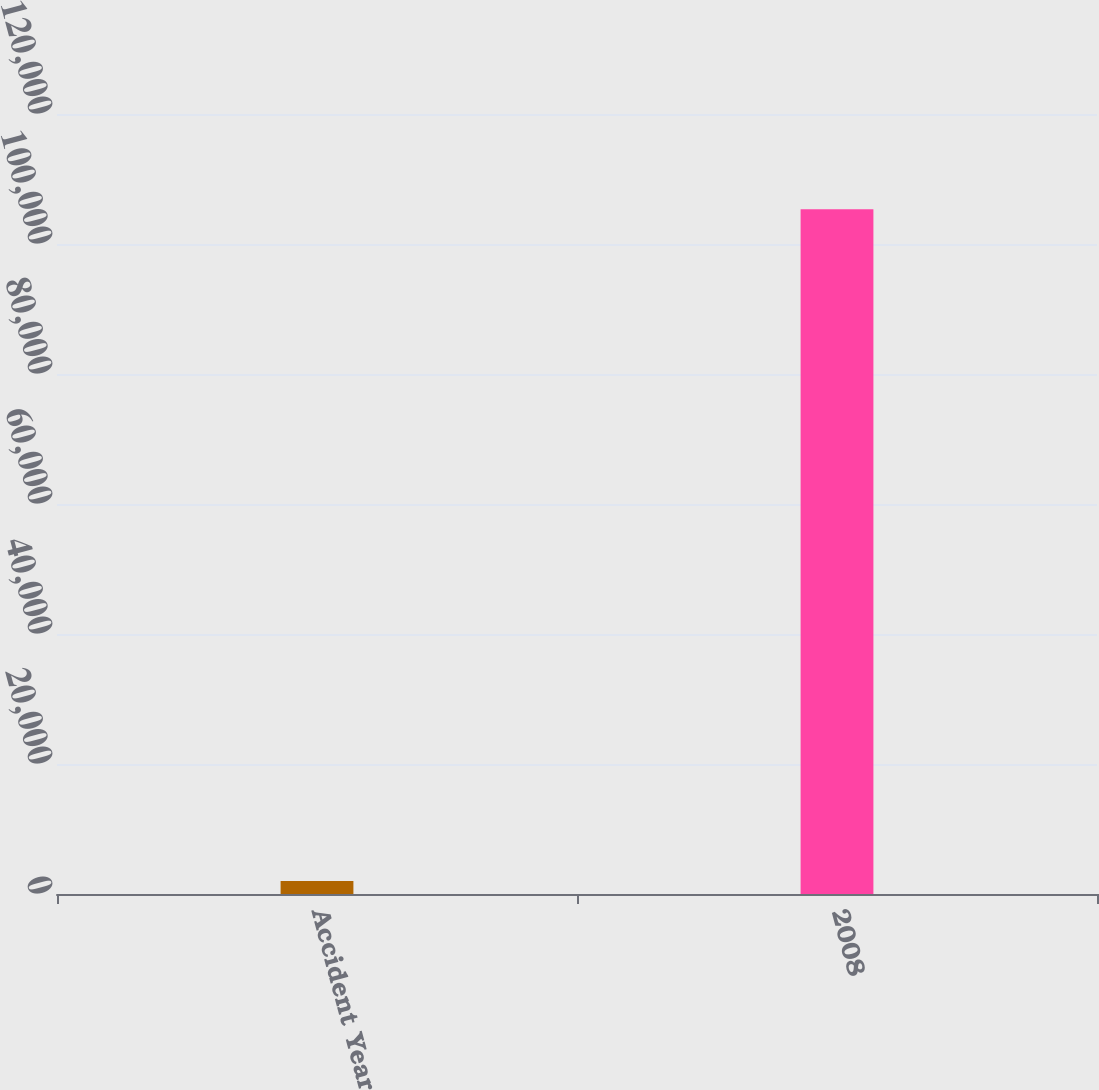<chart> <loc_0><loc_0><loc_500><loc_500><bar_chart><fcel>Accident Year<fcel>2008<nl><fcel>2015<fcel>105346<nl></chart> 